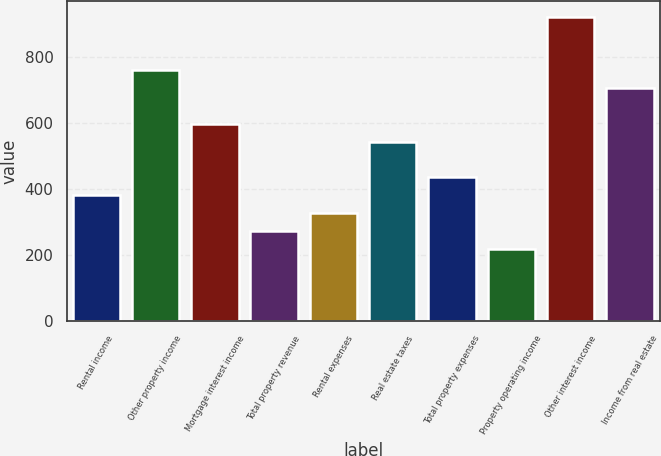<chart> <loc_0><loc_0><loc_500><loc_500><bar_chart><fcel>Rental income<fcel>Other property income<fcel>Mortgage interest income<fcel>Total property revenue<fcel>Rental expenses<fcel>Real estate taxes<fcel>Total property expenses<fcel>Property operating income<fcel>Other interest income<fcel>Income from real estate<nl><fcel>381.04<fcel>760.58<fcel>597.92<fcel>272.6<fcel>326.82<fcel>543.7<fcel>435.26<fcel>218.38<fcel>923.24<fcel>706.36<nl></chart> 